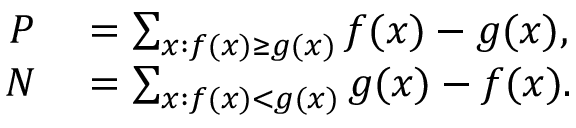<formula> <loc_0><loc_0><loc_500><loc_500>\begin{array} { r l } { P } & = \sum _ { x \colon f ( x ) \geq g ( x ) } f ( x ) - g ( x ) , } \\ { N } & = \sum _ { x \colon f ( x ) < g ( x ) } g ( x ) - f ( x ) . } \end{array}</formula> 